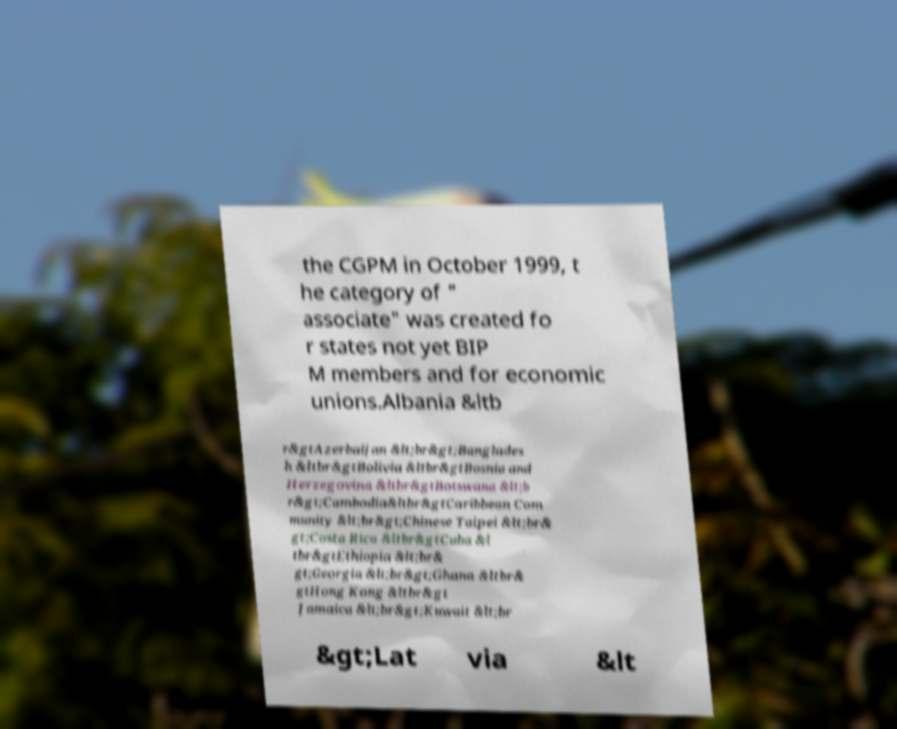What messages or text are displayed in this image? I need them in a readable, typed format. the CGPM in October 1999, t he category of " associate" was created fo r states not yet BIP M members and for economic unions.Albania &ltb r&gtAzerbaijan &lt;br&gt;Banglades h &ltbr&gtBolivia &ltbr&gtBosnia and Herzegovina &ltbr&gtBotswana &lt;b r&gt;Cambodia&ltbr&gtCaribbean Com munity &lt;br&gt;Chinese Taipei &lt;br& gt;Costa Rica &ltbr&gtCuba &l tbr&gtEthiopia &lt;br& gt;Georgia &lt;br&gt;Ghana &ltbr& gtHong Kong &ltbr&gt Jamaica &lt;br&gt;Kuwait &lt;br &gt;Lat via &lt 